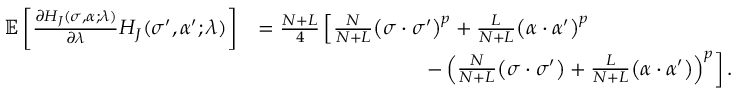Convert formula to latex. <formula><loc_0><loc_0><loc_500><loc_500>\begin{array} { r l } { \mathbb { E } \left [ \frac { \partial H _ { J } ( \sigma , \alpha ; \lambda ) } { \partial \lambda } H _ { J } ( \sigma ^ { \prime } , \alpha ^ { \prime } ; \lambda ) \right ] } & { = \frac { N + L } { 4 } \left [ \frac { N } { N + L } \left ( \sigma \cdot \sigma ^ { \prime } \right ) ^ { p } + \frac { L } { N + L } \left ( \alpha \cdot \alpha ^ { \prime } \right ) ^ { p } } \\ & { \quad - \left ( \frac { N } { N + L } \left ( \sigma \cdot \sigma ^ { \prime } \right ) + \frac { L } { N + L } \left ( \alpha \cdot \alpha ^ { \prime } \right ) \right ) ^ { p } \right ] . } \end{array}</formula> 